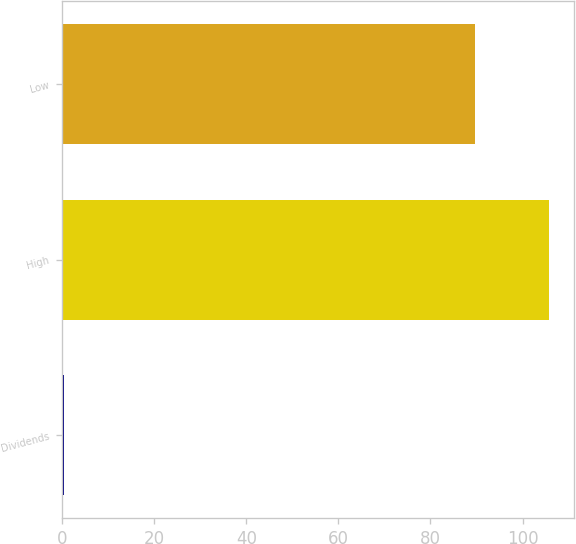Convert chart to OTSL. <chart><loc_0><loc_0><loc_500><loc_500><bar_chart><fcel>Dividends<fcel>High<fcel>Low<nl><fcel>0.35<fcel>105.84<fcel>89.58<nl></chart> 